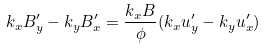<formula> <loc_0><loc_0><loc_500><loc_500>k _ { x } B _ { y } ^ { \prime } - k _ { y } B _ { x } ^ { \prime } = \frac { k _ { x } B } { \phi } ( k _ { x } u _ { y } ^ { \prime } - k _ { y } u _ { x } ^ { \prime } )</formula> 